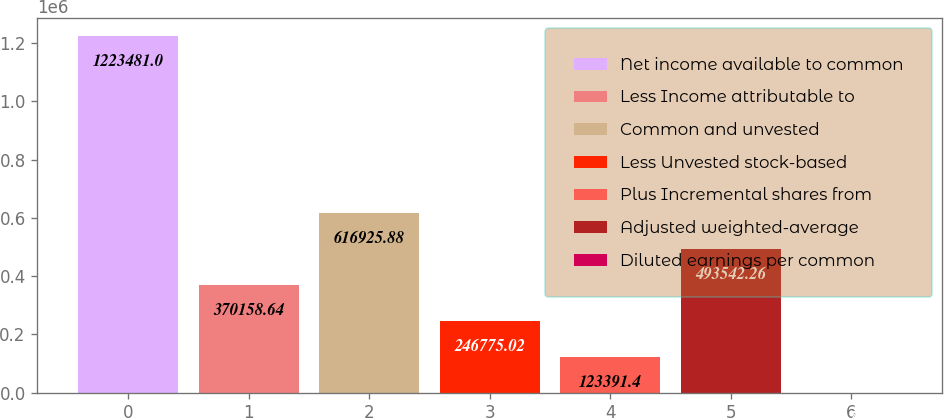Convert chart. <chart><loc_0><loc_0><loc_500><loc_500><bar_chart><fcel>Net income available to common<fcel>Less Income attributable to<fcel>Common and unvested<fcel>Less Unvested stock-based<fcel>Plus Incremental shares from<fcel>Adjusted weighted-average<fcel>Diluted earnings per common<nl><fcel>1.22348e+06<fcel>370159<fcel>616926<fcel>246775<fcel>123391<fcel>493542<fcel>7.78<nl></chart> 